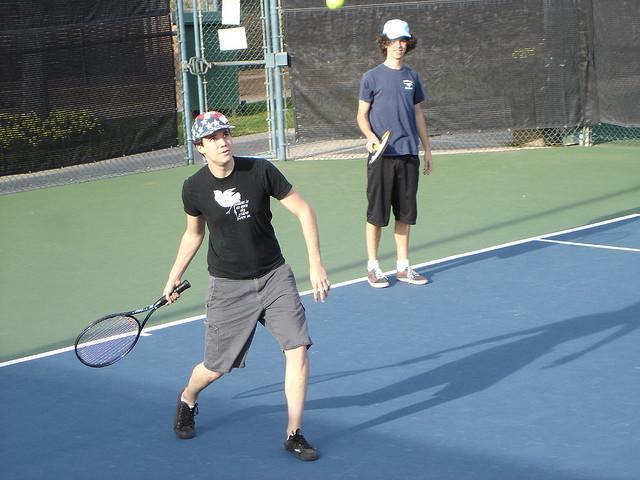What countries flag is on the man in the black shirts hat?
Choose the right answer and clarify with the format: 'Answer: answer
Rationale: rationale.'
Options: Finland, switzerland, germany, united states. Answer: united states.
Rationale: The us flag is red, white and blue. 